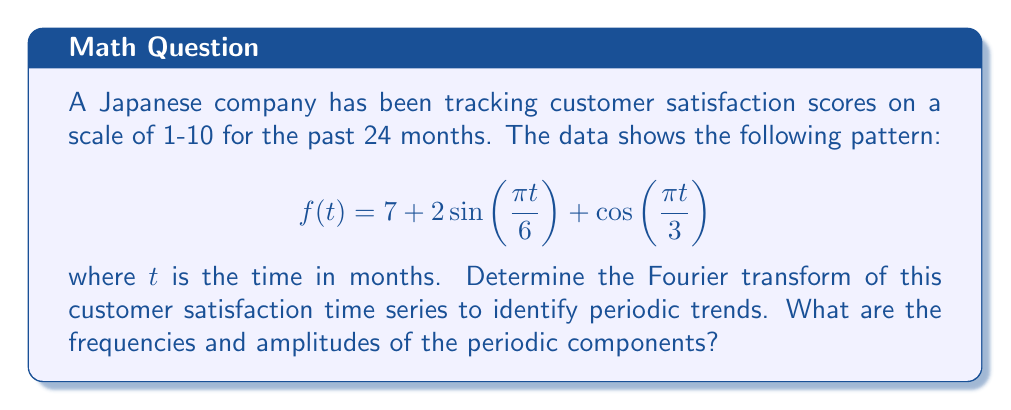Help me with this question. To solve this problem, we need to apply the Fourier transform to the given function. The Fourier transform of a function $f(t)$ is defined as:

$$F(\omega) = \int_{-\infty}^{\infty} f(t)e^{-i\omega t}dt$$

Let's break down the given function:

$f(t) = 7 + 2\sin(\frac{\pi t}{6}) + \cos(\frac{\pi t}{3})$

1. The constant term 7 will result in a Dirac delta function at $\omega = 0$ in the frequency domain.

2. For the sine term: $2\sin(\frac{\pi t}{6})$
   We can use the identity: $\sin(at) = \frac{1}{2i}(e^{iat} - e^{-iat})$
   This will result in two delta functions at $\omega = \pm \frac{\pi}{6}$

3. For the cosine term: $\cos(\frac{\pi t}{3})$
   We can use the identity: $\cos(at) = \frac{1}{2}(e^{iat} + e^{-iat})$
   This will result in two delta functions at $\omega = \pm \frac{\pi}{3}$

Combining these results, the Fourier transform of $f(t)$ is:

$$F(\omega) = 14\pi\delta(\omega) + i\pi(\delta(\omega - \frac{\pi}{6}) - \delta(\omega + \frac{\pi}{6})) + \frac{\pi}{2}(\delta(\omega - \frac{\pi}{3}) + \delta(\omega + \frac{\pi}{3}))$$

To identify the frequencies and amplitudes:

1. The constant term (7) corresponds to a frequency of 0 with amplitude 14π.
2. The sine term corresponds to frequencies $\pm \frac{\pi}{6}$ (period of 12 months) with amplitude π.
3. The cosine term corresponds to frequencies $\pm \frac{\pi}{3}$ (period of 6 months) with amplitude $\frac{\pi}{2}$.
Answer: The Fourier transform of the customer satisfaction time series is:

$$F(\omega) = 14\pi\delta(\omega) + i\pi(\delta(\omega - \frac{\pi}{6}) - \delta(\omega + \frac{\pi}{6})) + \frac{\pi}{2}(\delta(\omega - \frac{\pi}{3}) + \delta(\omega + \frac{\pi}{3}))$$

The periodic components are:
1. Frequency 0 (constant term) with amplitude 14π
2. Frequencies $\pm \frac{\pi}{6}$ (12-month period) with amplitude π
3. Frequencies $\pm \frac{\pi}{3}$ (6-month period) with amplitude $\frac{\pi}{2}$ 